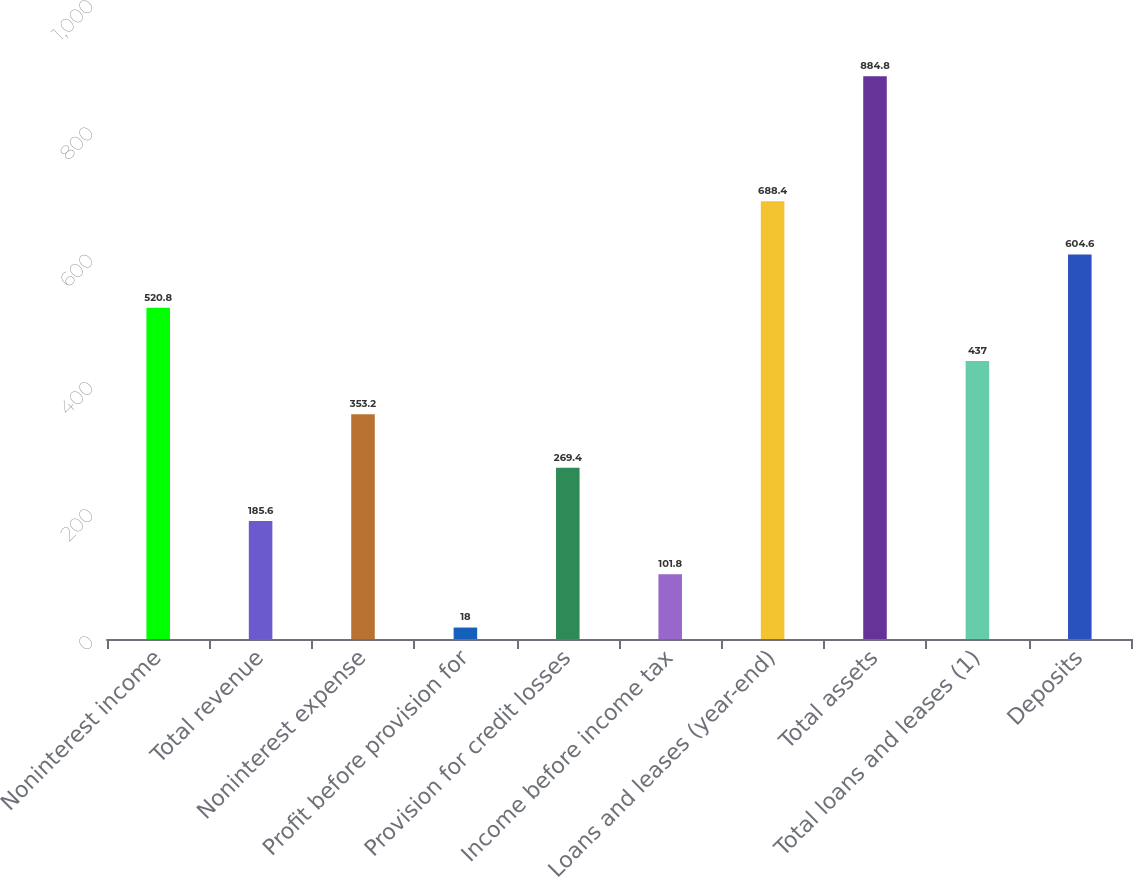<chart> <loc_0><loc_0><loc_500><loc_500><bar_chart><fcel>Noninterest income<fcel>Total revenue<fcel>Noninterest expense<fcel>Profit before provision for<fcel>Provision for credit losses<fcel>Income before income tax<fcel>Loans and leases (year-end)<fcel>Total assets<fcel>Total loans and leases (1)<fcel>Deposits<nl><fcel>520.8<fcel>185.6<fcel>353.2<fcel>18<fcel>269.4<fcel>101.8<fcel>688.4<fcel>884.8<fcel>437<fcel>604.6<nl></chart> 